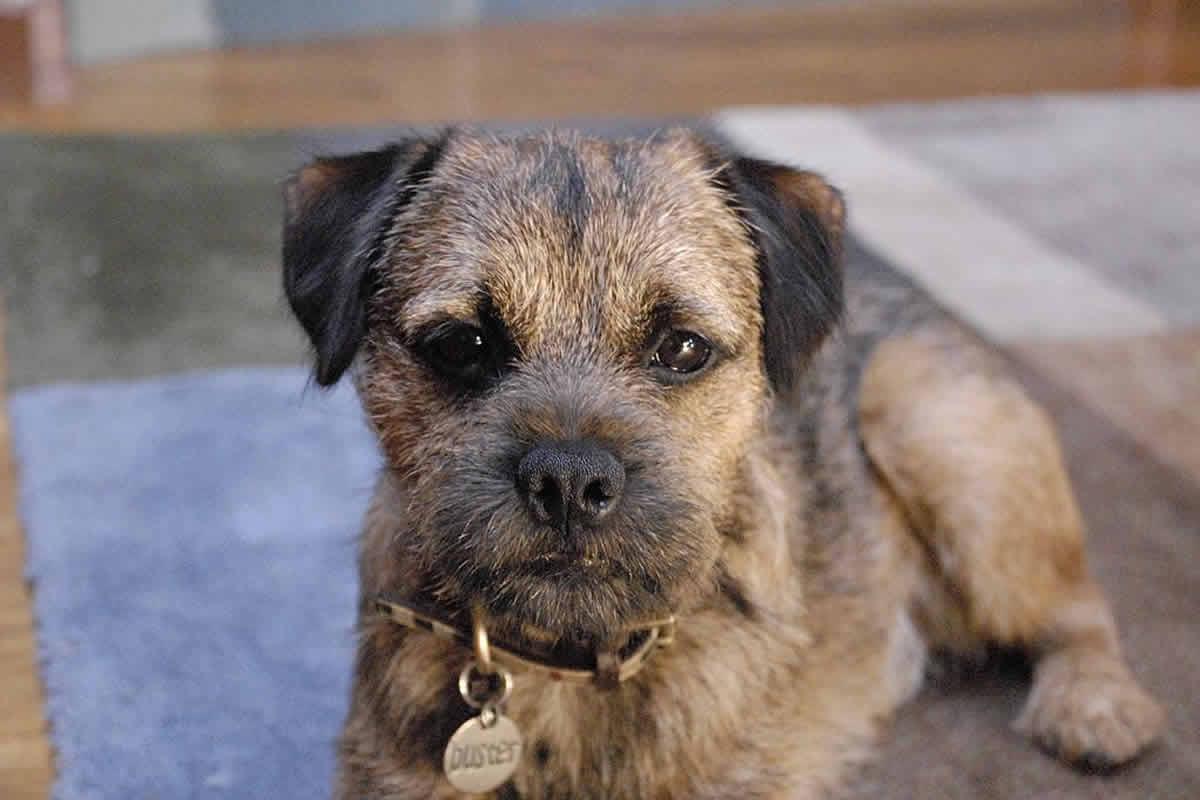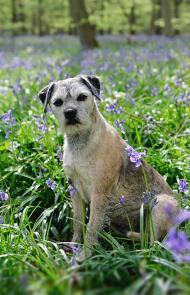The first image is the image on the left, the second image is the image on the right. Considering the images on both sides, is "At least two dogs are standing." valid? Answer yes or no. No. The first image is the image on the left, the second image is the image on the right. Analyze the images presented: Is the assertion "The left and right image contains the same number of dogs with at least one sitting in grass." valid? Answer yes or no. Yes. 